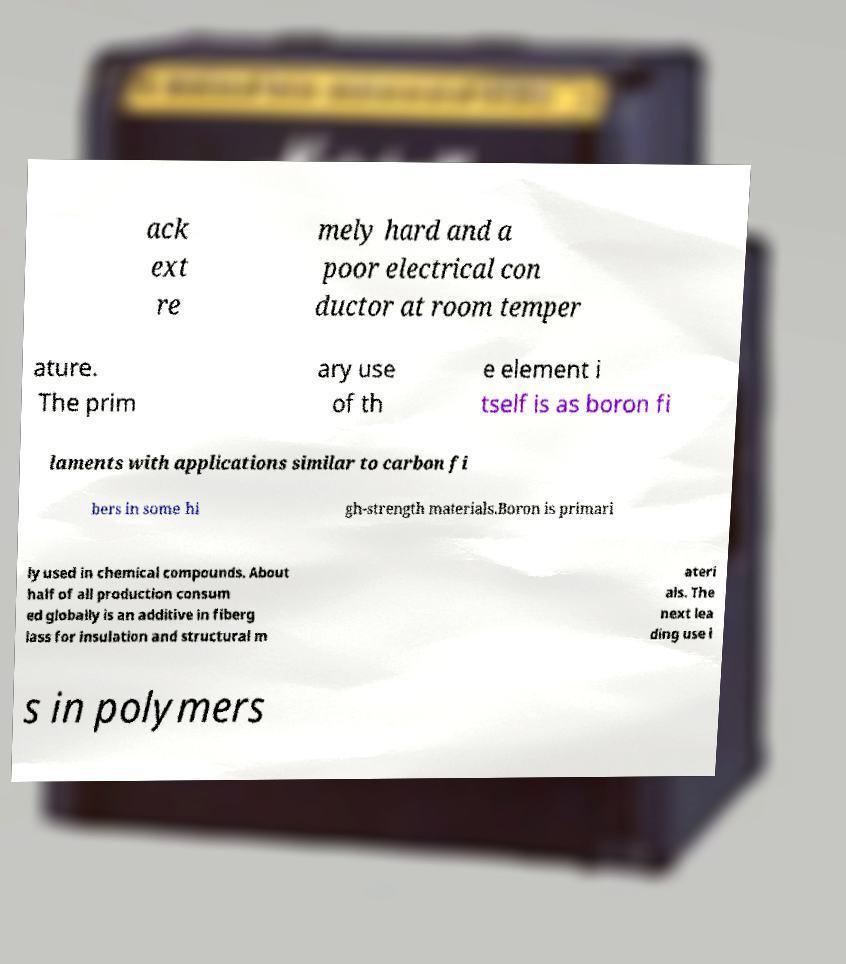What messages or text are displayed in this image? I need them in a readable, typed format. ack ext re mely hard and a poor electrical con ductor at room temper ature. The prim ary use of th e element i tself is as boron fi laments with applications similar to carbon fi bers in some hi gh-strength materials.Boron is primari ly used in chemical compounds. About half of all production consum ed globally is an additive in fiberg lass for insulation and structural m ateri als. The next lea ding use i s in polymers 